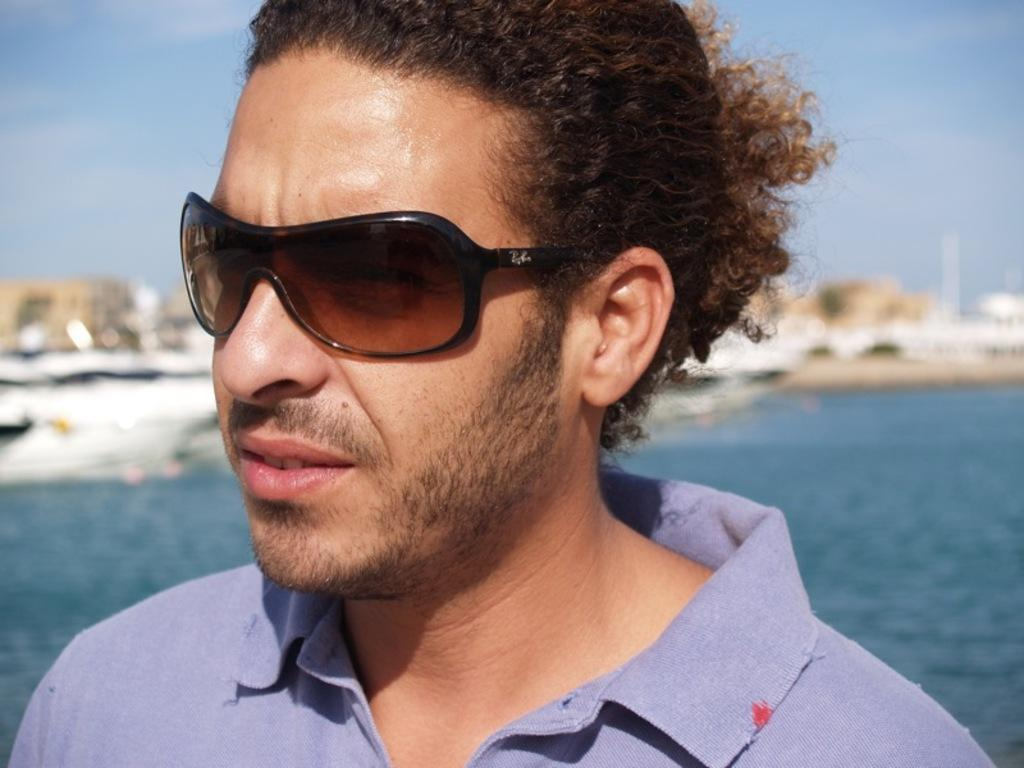Who or what is present in the image? There is a person in the image. What is the person wearing that is visible in the image? The person is wearing sunglasses. What can be seen in the background of the image? There is sky, ships, and water visible in the background of the image. What type of teaching is the person conducting in the image? There is no indication of teaching or any educational activity in the image. 